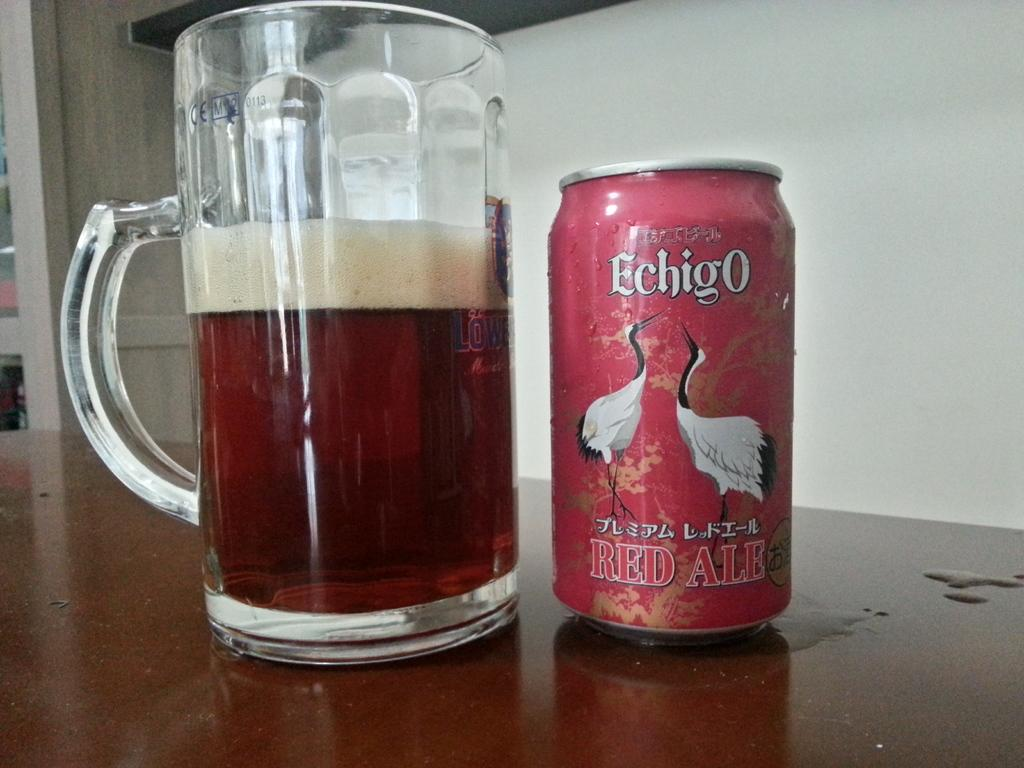<image>
Provide a brief description of the given image. A can of Echigo Red Ale next to a tall mug filled with presumably the same drink. 